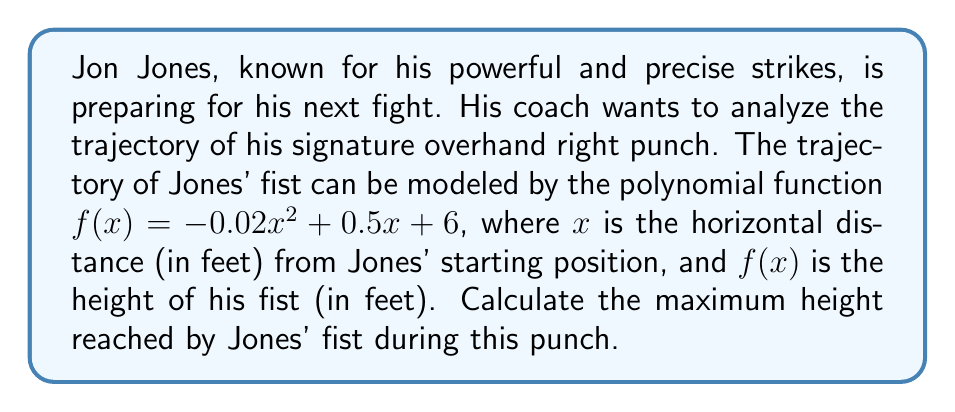Provide a solution to this math problem. To find the maximum height of Jon Jones' punch, we need to find the vertex of the parabola described by the given polynomial function. The function is in the form $f(x) = ax^2 + bx + c$, where:

$a = -0.02$
$b = 0.5$
$c = 6$

For a quadratic function, the x-coordinate of the vertex is given by the formula:

$$x = -\frac{b}{2a}$$

Substituting our values:

$$x = -\frac{0.5}{2(-0.02)} = -\frac{0.5}{-0.04} = 12.5$$

This means the fist reaches its maximum height when $x = 12.5$ feet.

To find the maximum height, we need to calculate $f(12.5)$:

$$\begin{align*}
f(12.5) &= -0.02(12.5)^2 + 0.5(12.5) + 6 \\
&= -0.02(156.25) + 6.25 + 6 \\
&= -3.125 + 6.25 + 6 \\
&= 9.125
\end{align*}$$

Therefore, the maximum height reached by Jones' fist is 9.125 feet.
Answer: The maximum height reached by Jon Jones' fist during the punch is 9.125 feet. 